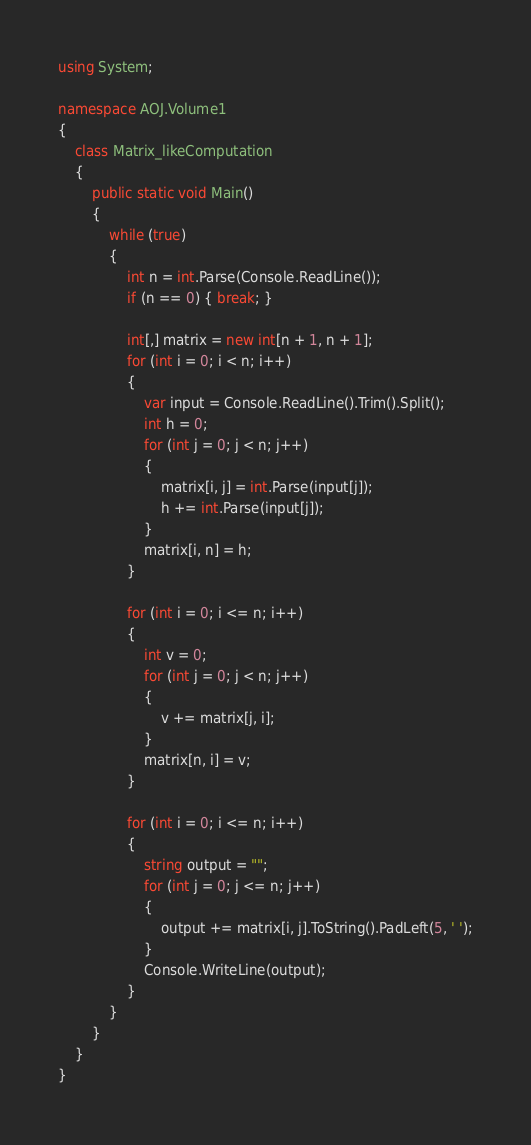<code> <loc_0><loc_0><loc_500><loc_500><_C#_>using System;

namespace AOJ.Volume1
{
    class Matrix_likeComputation
    {
        public static void Main()
        {
            while (true)
            {
                int n = int.Parse(Console.ReadLine());
                if (n == 0) { break; }

                int[,] matrix = new int[n + 1, n + 1];
                for (int i = 0; i < n; i++)
                {
                    var input = Console.ReadLine().Trim().Split();
                    int h = 0;
                    for (int j = 0; j < n; j++)
                    {
                        matrix[i, j] = int.Parse(input[j]);
                        h += int.Parse(input[j]);
                    }
                    matrix[i, n] = h;
                }

                for (int i = 0; i <= n; i++)
                {
                    int v = 0;
                    for (int j = 0; j < n; j++)
                    {
                        v += matrix[j, i];
                    }
                    matrix[n, i] = v;
                }

                for (int i = 0; i <= n; i++)
                {
                    string output = "";
                    for (int j = 0; j <= n; j++)
                    {
                        output += matrix[i, j].ToString().PadLeft(5, ' ');
                    }
                    Console.WriteLine(output);
                }
            }
        }
    }
}</code> 